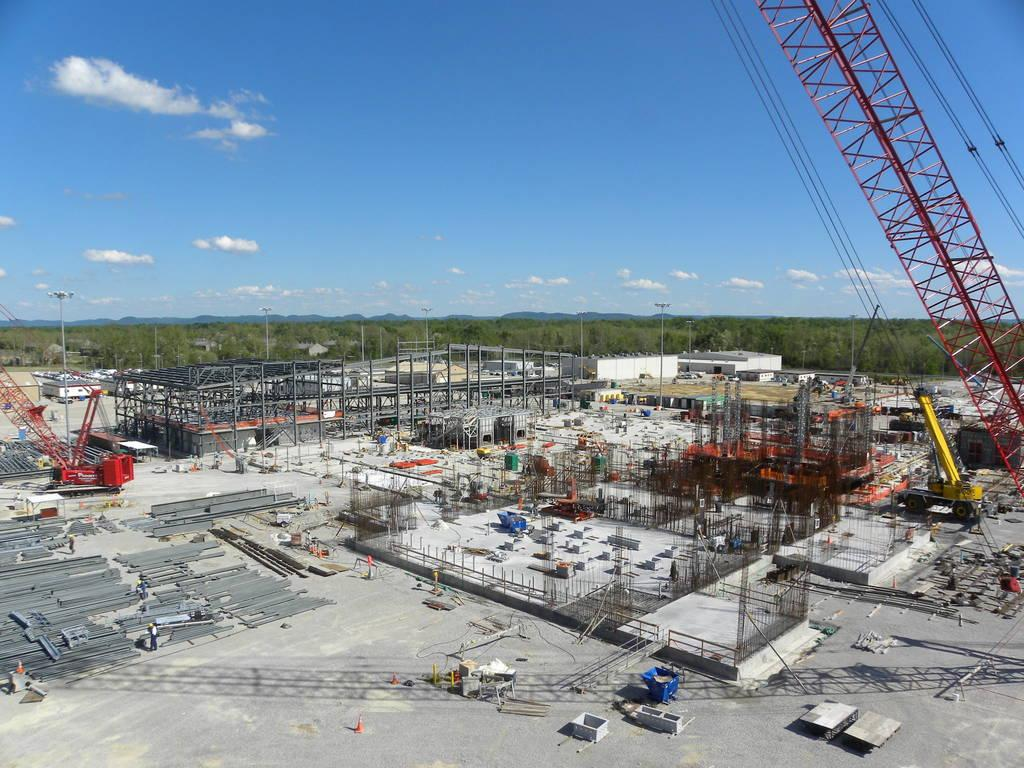What type of area is shown in the image? The image depicts an industrial area. What can be seen within the industrial area? There are many machines, rods, and pillars in the image. What is the surrounding environment like? The industrial area is surrounded by green trees. What is the color of the sky in the image? The sky is blue in the image. How many ducks are swimming in the blue sky in the image? There are no ducks present in the image, and the sky is not depicted as a body of water where ducks could swim. 